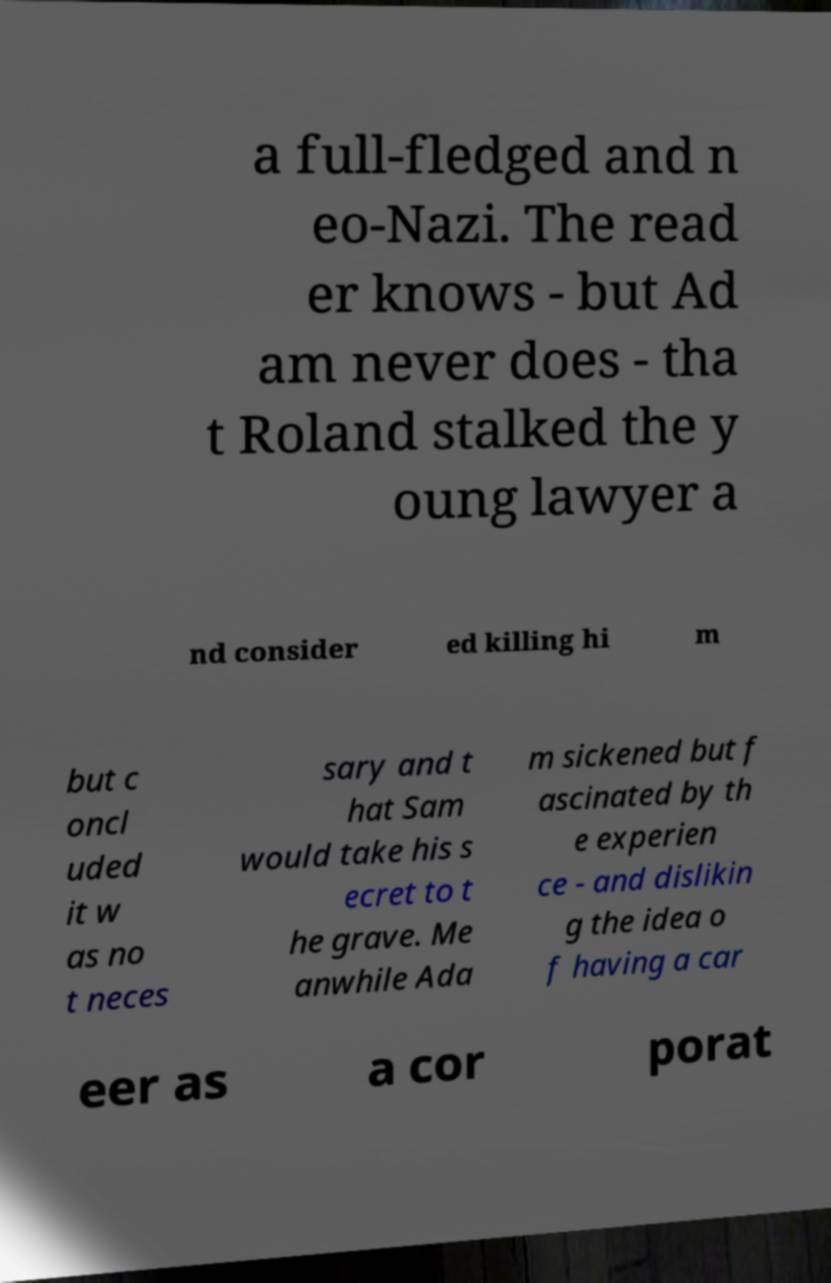What messages or text are displayed in this image? I need them in a readable, typed format. a full-fledged and n eo-Nazi. The read er knows - but Ad am never does - tha t Roland stalked the y oung lawyer a nd consider ed killing hi m but c oncl uded it w as no t neces sary and t hat Sam would take his s ecret to t he grave. Me anwhile Ada m sickened but f ascinated by th e experien ce - and dislikin g the idea o f having a car eer as a cor porat 